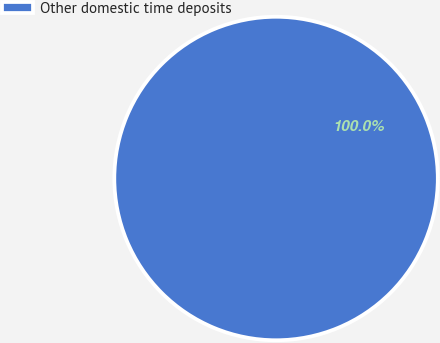<chart> <loc_0><loc_0><loc_500><loc_500><pie_chart><fcel>Other domestic time deposits<nl><fcel>100.0%<nl></chart> 